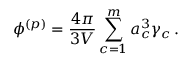<formula> <loc_0><loc_0><loc_500><loc_500>\phi ^ { ( p ) } = \frac { 4 \pi } { 3 V } \sum _ { c = 1 } ^ { m } a _ { c } ^ { 3 } \gamma _ { c } \, .</formula> 